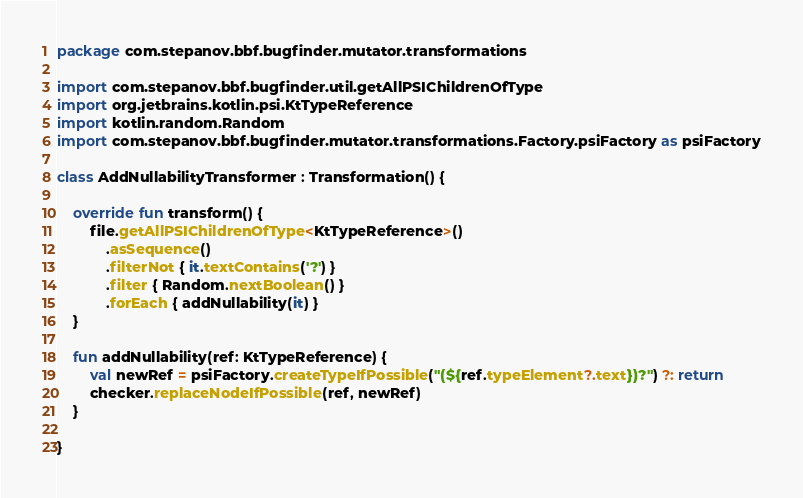<code> <loc_0><loc_0><loc_500><loc_500><_Kotlin_>package com.stepanov.bbf.bugfinder.mutator.transformations

import com.stepanov.bbf.bugfinder.util.getAllPSIChildrenOfType
import org.jetbrains.kotlin.psi.KtTypeReference
import kotlin.random.Random
import com.stepanov.bbf.bugfinder.mutator.transformations.Factory.psiFactory as psiFactory

class AddNullabilityTransformer : Transformation() {

    override fun transform() {
        file.getAllPSIChildrenOfType<KtTypeReference>()
            .asSequence()
            .filterNot { it.textContains('?') }
            .filter { Random.nextBoolean() }
            .forEach { addNullability(it) }
    }

    fun addNullability(ref: KtTypeReference) {
        val newRef = psiFactory.createTypeIfPossible("(${ref.typeElement?.text})?") ?: return
        checker.replaceNodeIfPossible(ref, newRef)
    }

}</code> 